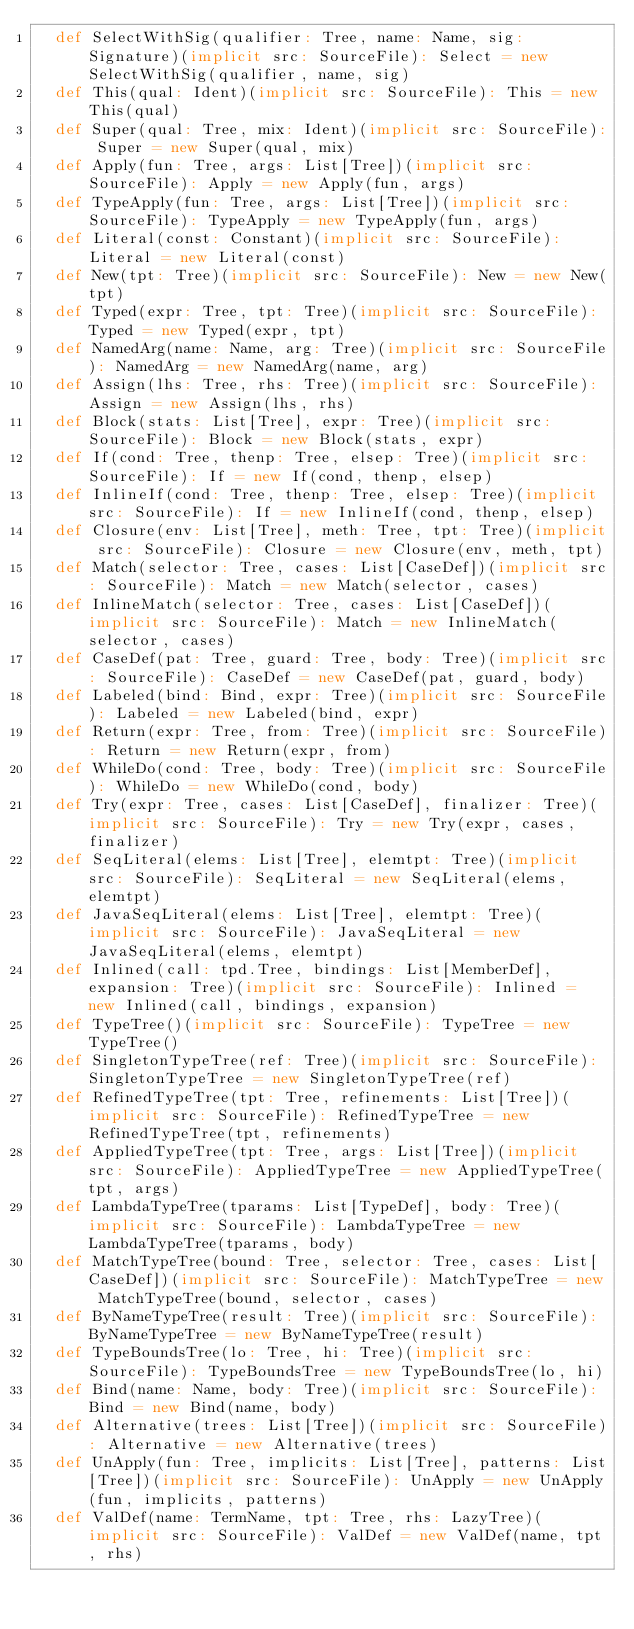<code> <loc_0><loc_0><loc_500><loc_500><_Scala_>  def SelectWithSig(qualifier: Tree, name: Name, sig: Signature)(implicit src: SourceFile): Select = new SelectWithSig(qualifier, name, sig)
  def This(qual: Ident)(implicit src: SourceFile): This = new This(qual)
  def Super(qual: Tree, mix: Ident)(implicit src: SourceFile): Super = new Super(qual, mix)
  def Apply(fun: Tree, args: List[Tree])(implicit src: SourceFile): Apply = new Apply(fun, args)
  def TypeApply(fun: Tree, args: List[Tree])(implicit src: SourceFile): TypeApply = new TypeApply(fun, args)
  def Literal(const: Constant)(implicit src: SourceFile): Literal = new Literal(const)
  def New(tpt: Tree)(implicit src: SourceFile): New = new New(tpt)
  def Typed(expr: Tree, tpt: Tree)(implicit src: SourceFile): Typed = new Typed(expr, tpt)
  def NamedArg(name: Name, arg: Tree)(implicit src: SourceFile): NamedArg = new NamedArg(name, arg)
  def Assign(lhs: Tree, rhs: Tree)(implicit src: SourceFile): Assign = new Assign(lhs, rhs)
  def Block(stats: List[Tree], expr: Tree)(implicit src: SourceFile): Block = new Block(stats, expr)
  def If(cond: Tree, thenp: Tree, elsep: Tree)(implicit src: SourceFile): If = new If(cond, thenp, elsep)
  def InlineIf(cond: Tree, thenp: Tree, elsep: Tree)(implicit src: SourceFile): If = new InlineIf(cond, thenp, elsep)
  def Closure(env: List[Tree], meth: Tree, tpt: Tree)(implicit src: SourceFile): Closure = new Closure(env, meth, tpt)
  def Match(selector: Tree, cases: List[CaseDef])(implicit src: SourceFile): Match = new Match(selector, cases)
  def InlineMatch(selector: Tree, cases: List[CaseDef])(implicit src: SourceFile): Match = new InlineMatch(selector, cases)
  def CaseDef(pat: Tree, guard: Tree, body: Tree)(implicit src: SourceFile): CaseDef = new CaseDef(pat, guard, body)
  def Labeled(bind: Bind, expr: Tree)(implicit src: SourceFile): Labeled = new Labeled(bind, expr)
  def Return(expr: Tree, from: Tree)(implicit src: SourceFile): Return = new Return(expr, from)
  def WhileDo(cond: Tree, body: Tree)(implicit src: SourceFile): WhileDo = new WhileDo(cond, body)
  def Try(expr: Tree, cases: List[CaseDef], finalizer: Tree)(implicit src: SourceFile): Try = new Try(expr, cases, finalizer)
  def SeqLiteral(elems: List[Tree], elemtpt: Tree)(implicit src: SourceFile): SeqLiteral = new SeqLiteral(elems, elemtpt)
  def JavaSeqLiteral(elems: List[Tree], elemtpt: Tree)(implicit src: SourceFile): JavaSeqLiteral = new JavaSeqLiteral(elems, elemtpt)
  def Inlined(call: tpd.Tree, bindings: List[MemberDef], expansion: Tree)(implicit src: SourceFile): Inlined = new Inlined(call, bindings, expansion)
  def TypeTree()(implicit src: SourceFile): TypeTree = new TypeTree()
  def SingletonTypeTree(ref: Tree)(implicit src: SourceFile): SingletonTypeTree = new SingletonTypeTree(ref)
  def RefinedTypeTree(tpt: Tree, refinements: List[Tree])(implicit src: SourceFile): RefinedTypeTree = new RefinedTypeTree(tpt, refinements)
  def AppliedTypeTree(tpt: Tree, args: List[Tree])(implicit src: SourceFile): AppliedTypeTree = new AppliedTypeTree(tpt, args)
  def LambdaTypeTree(tparams: List[TypeDef], body: Tree)(implicit src: SourceFile): LambdaTypeTree = new LambdaTypeTree(tparams, body)
  def MatchTypeTree(bound: Tree, selector: Tree, cases: List[CaseDef])(implicit src: SourceFile): MatchTypeTree = new MatchTypeTree(bound, selector, cases)
  def ByNameTypeTree(result: Tree)(implicit src: SourceFile): ByNameTypeTree = new ByNameTypeTree(result)
  def TypeBoundsTree(lo: Tree, hi: Tree)(implicit src: SourceFile): TypeBoundsTree = new TypeBoundsTree(lo, hi)
  def Bind(name: Name, body: Tree)(implicit src: SourceFile): Bind = new Bind(name, body)
  def Alternative(trees: List[Tree])(implicit src: SourceFile): Alternative = new Alternative(trees)
  def UnApply(fun: Tree, implicits: List[Tree], patterns: List[Tree])(implicit src: SourceFile): UnApply = new UnApply(fun, implicits, patterns)
  def ValDef(name: TermName, tpt: Tree, rhs: LazyTree)(implicit src: SourceFile): ValDef = new ValDef(name, tpt, rhs)</code> 